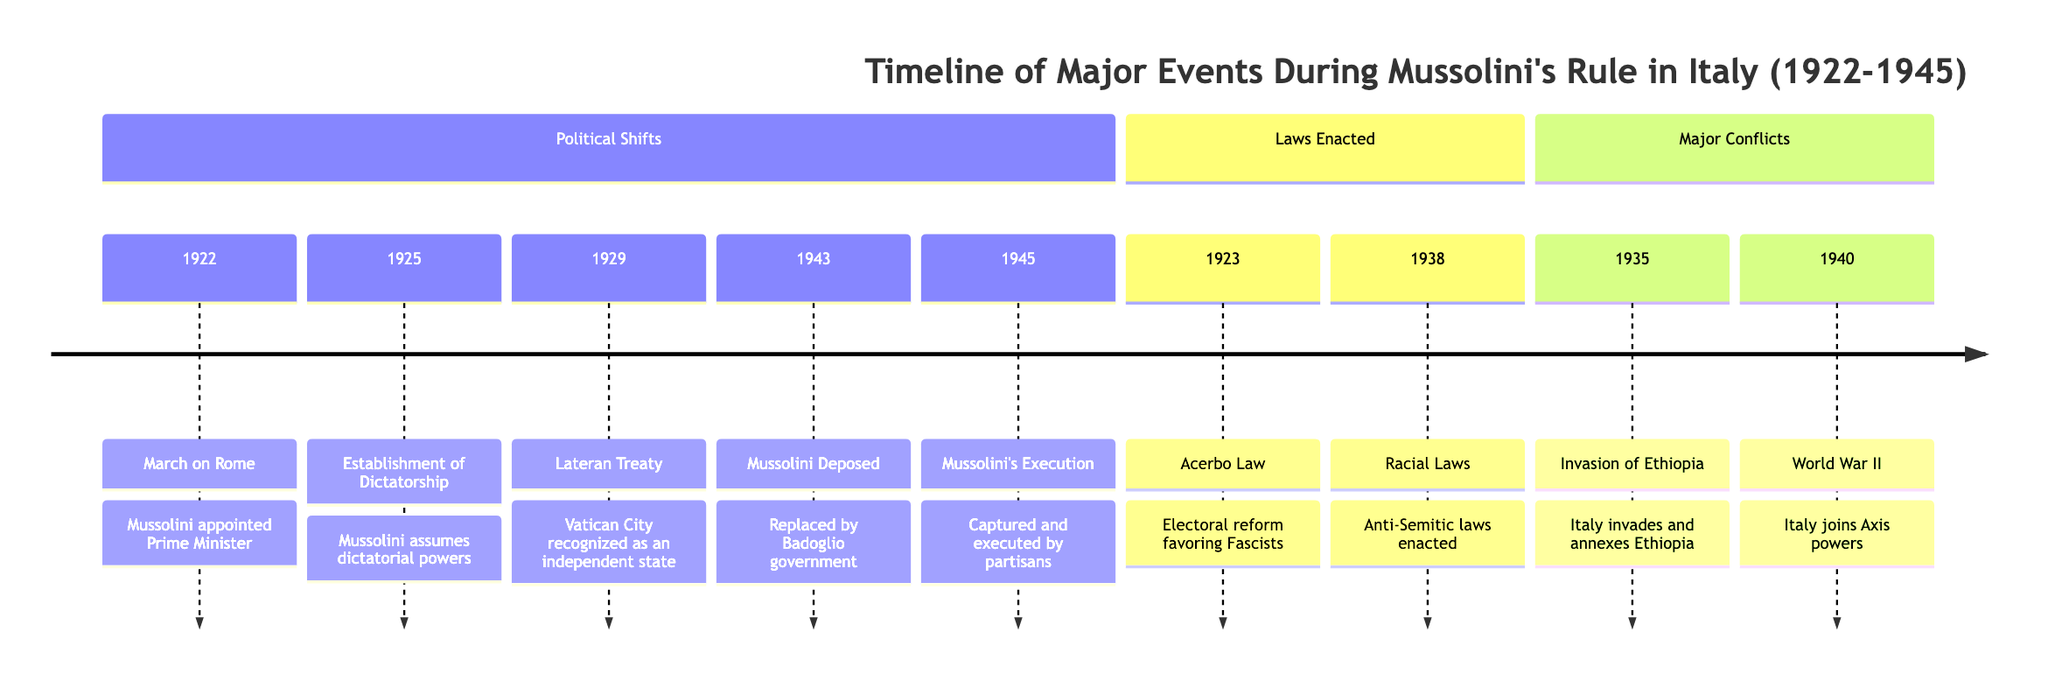What major event marks the beginning of Mussolini's rule in Italy? The diagram indicates that Mussolini was appointed Prime Minister in 1922, which is the first event listed under Political Shifts. Thus, this marks the beginning of his rule.
Answer: 1922: March on Rome Which law was enacted to favor the Fascists? Referring to the Laws Enacted section, the Acerbo Law, noted in 1923, is specifically described as an electoral reform that favored the Fascist party, making it the key law of interest.
Answer: Acerbo Law How many major conflicts are listed in the diagram? By counting the entries under the Major Conflicts section, there are three distinct events listed: the invasion of Ethiopia in 1935 and Italy's participation in World War II in 1940. Therefore, the total number of conflicts is three.
Answer: 3 What significant treaty was enacted in 1929? In the Laws Enacted section, the Lateran Treaty is mentioned as occurring in 1929, which recognized Vatican City as an independent state, making it the significant treaty from that year.
Answer: Lateran Treaty Which event marks the end of Mussolini's rule? The final event under Political Shifts indicates that Mussolini was captured and executed by partisans in 1945, which is clearly marked as the end of his rule in the timeline.
Answer: 1945: Mussolini's Execution What major conflict did Italy engage in 1940? Looking at the Major Conflicts section, it states that Italy joined the Axis powers in 1940 during World War II, identifying this as the significant conflict for that year.
Answer: World War II What year was the establishment of Mussolini's dictatorship? The timeline specifies the year 1925 for the establishment of Mussolini's dictatorship, as listed in the Political Shifts section. This date marks when he assumed dictatorial powers.
Answer: 1925: Establishment of Dictatorship What was a significant consequence of the Racial Laws enacted in 1938? The Racial Laws enacted in 1938, as part of the Laws Enacted section, were anti-Semitic laws. This indicates a significant socio-political consequence of these laws at that time.
Answer: Anti-Semitic laws 